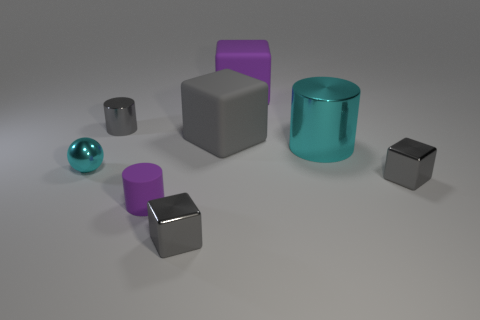Is there anything else that is the same shape as the tiny cyan thing?
Your answer should be compact. No. There is a matte object that is both behind the small cyan object and in front of the tiny gray cylinder; what is its size?
Your answer should be compact. Large. The tiny cyan metallic thing is what shape?
Provide a succinct answer. Sphere. There is a large matte block in front of the big purple thing; are there any tiny gray metal things in front of it?
Your answer should be compact. Yes. There is a small rubber cylinder that is left of the big metal cylinder; what number of gray blocks are behind it?
Ensure brevity in your answer.  2. What material is the gray cylinder that is the same size as the cyan metallic ball?
Your response must be concise. Metal. There is a cyan shiny thing that is on the right side of the tiny metallic ball; is it the same shape as the tiny purple object?
Ensure brevity in your answer.  Yes. Are there more gray things to the right of the big metal cylinder than big cyan objects on the left side of the tiny gray cylinder?
Your answer should be very brief. Yes. What number of tiny cyan balls have the same material as the cyan cylinder?
Offer a very short reply. 1. Does the purple cylinder have the same size as the cyan shiny ball?
Give a very brief answer. Yes. 